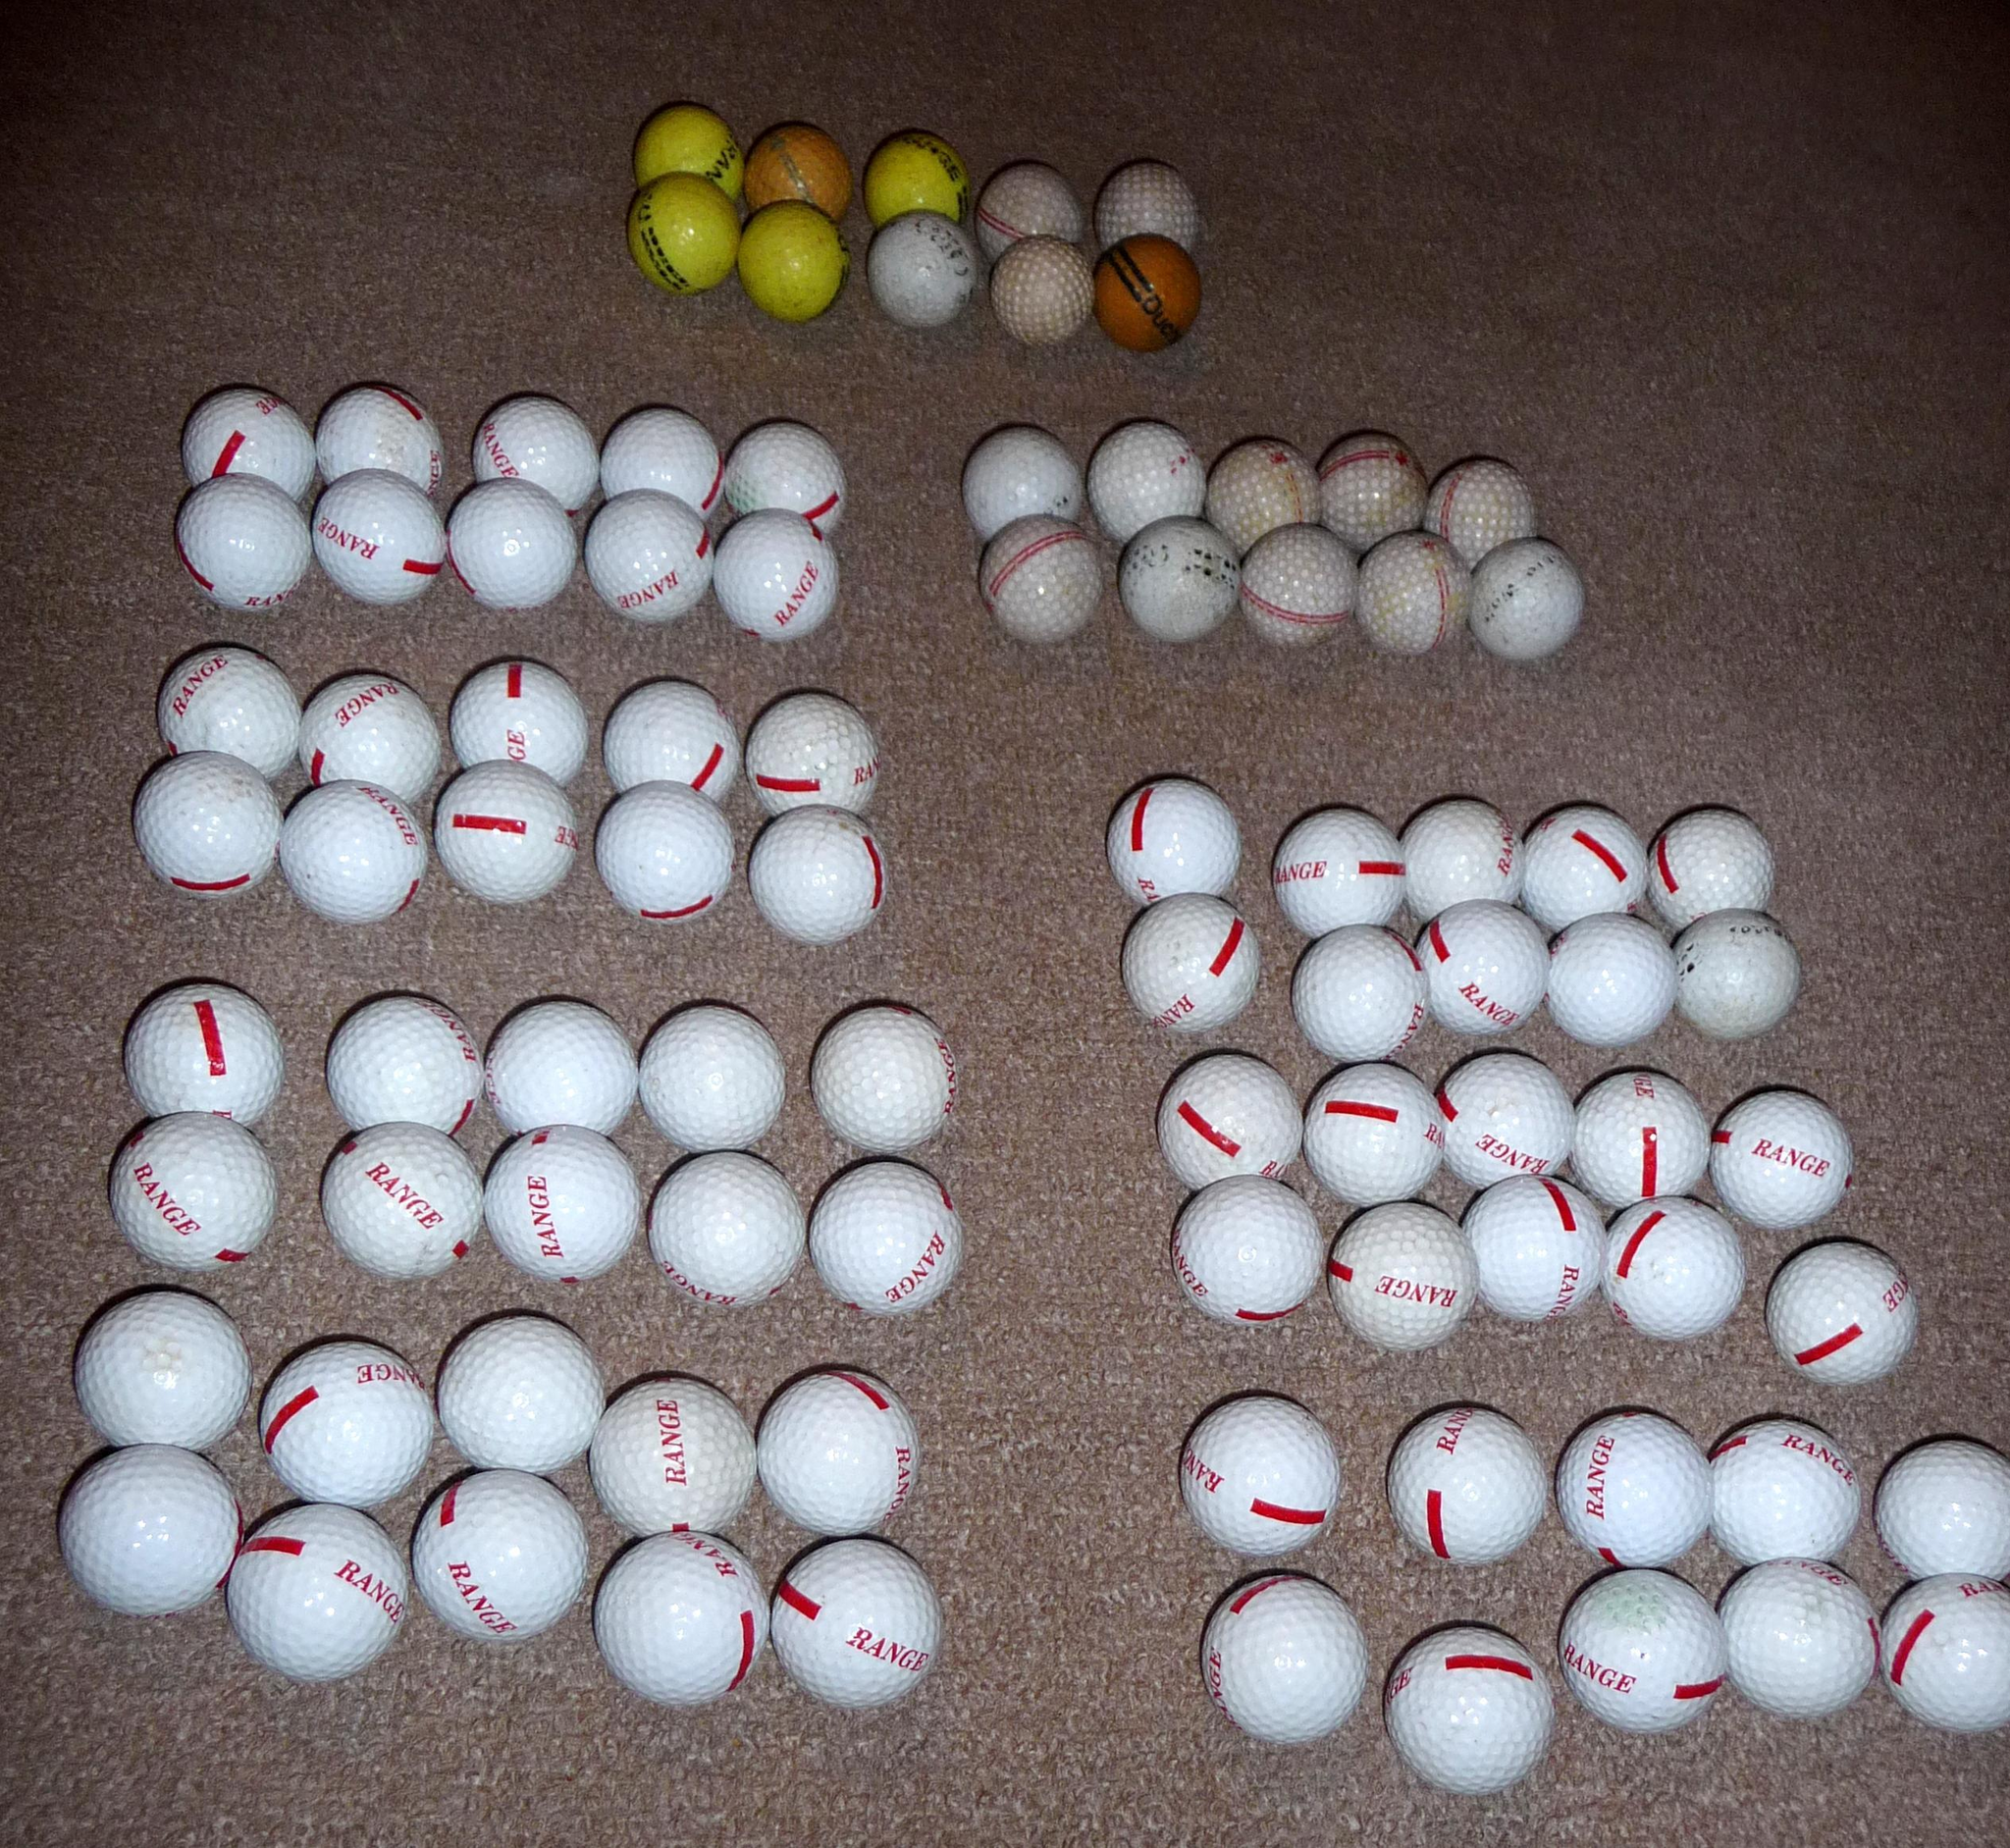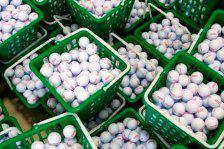The first image is the image on the left, the second image is the image on the right. Assess this claim about the two images: "All the balls in the image on the right are white.". Correct or not? Answer yes or no. Yes. The first image is the image on the left, the second image is the image on the right. Examine the images to the left and right. Is the description "An image shows yellow and orange balls among white golf balls." accurate? Answer yes or no. Yes. 